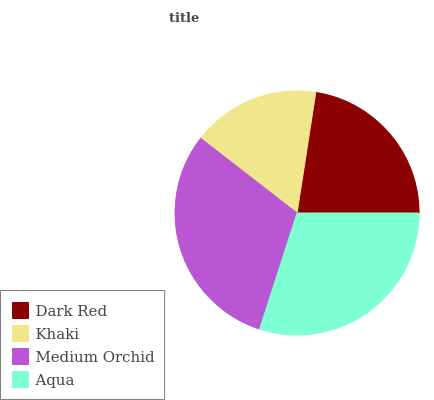Is Khaki the minimum?
Answer yes or no. Yes. Is Medium Orchid the maximum?
Answer yes or no. Yes. Is Medium Orchid the minimum?
Answer yes or no. No. Is Khaki the maximum?
Answer yes or no. No. Is Medium Orchid greater than Khaki?
Answer yes or no. Yes. Is Khaki less than Medium Orchid?
Answer yes or no. Yes. Is Khaki greater than Medium Orchid?
Answer yes or no. No. Is Medium Orchid less than Khaki?
Answer yes or no. No. Is Aqua the high median?
Answer yes or no. Yes. Is Dark Red the low median?
Answer yes or no. Yes. Is Dark Red the high median?
Answer yes or no. No. Is Medium Orchid the low median?
Answer yes or no. No. 